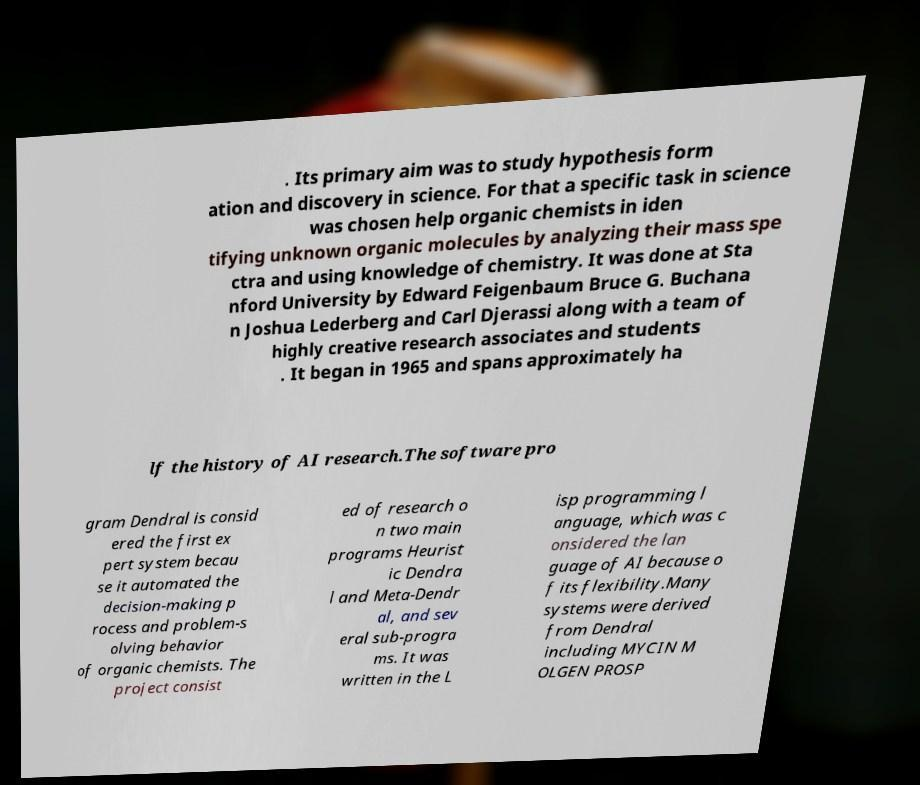There's text embedded in this image that I need extracted. Can you transcribe it verbatim? . Its primary aim was to study hypothesis form ation and discovery in science. For that a specific task in science was chosen help organic chemists in iden tifying unknown organic molecules by analyzing their mass spe ctra and using knowledge of chemistry. It was done at Sta nford University by Edward Feigenbaum Bruce G. Buchana n Joshua Lederberg and Carl Djerassi along with a team of highly creative research associates and students . It began in 1965 and spans approximately ha lf the history of AI research.The software pro gram Dendral is consid ered the first ex pert system becau se it automated the decision-making p rocess and problem-s olving behavior of organic chemists. The project consist ed of research o n two main programs Heurist ic Dendra l and Meta-Dendr al, and sev eral sub-progra ms. It was written in the L isp programming l anguage, which was c onsidered the lan guage of AI because o f its flexibility.Many systems were derived from Dendral including MYCIN M OLGEN PROSP 